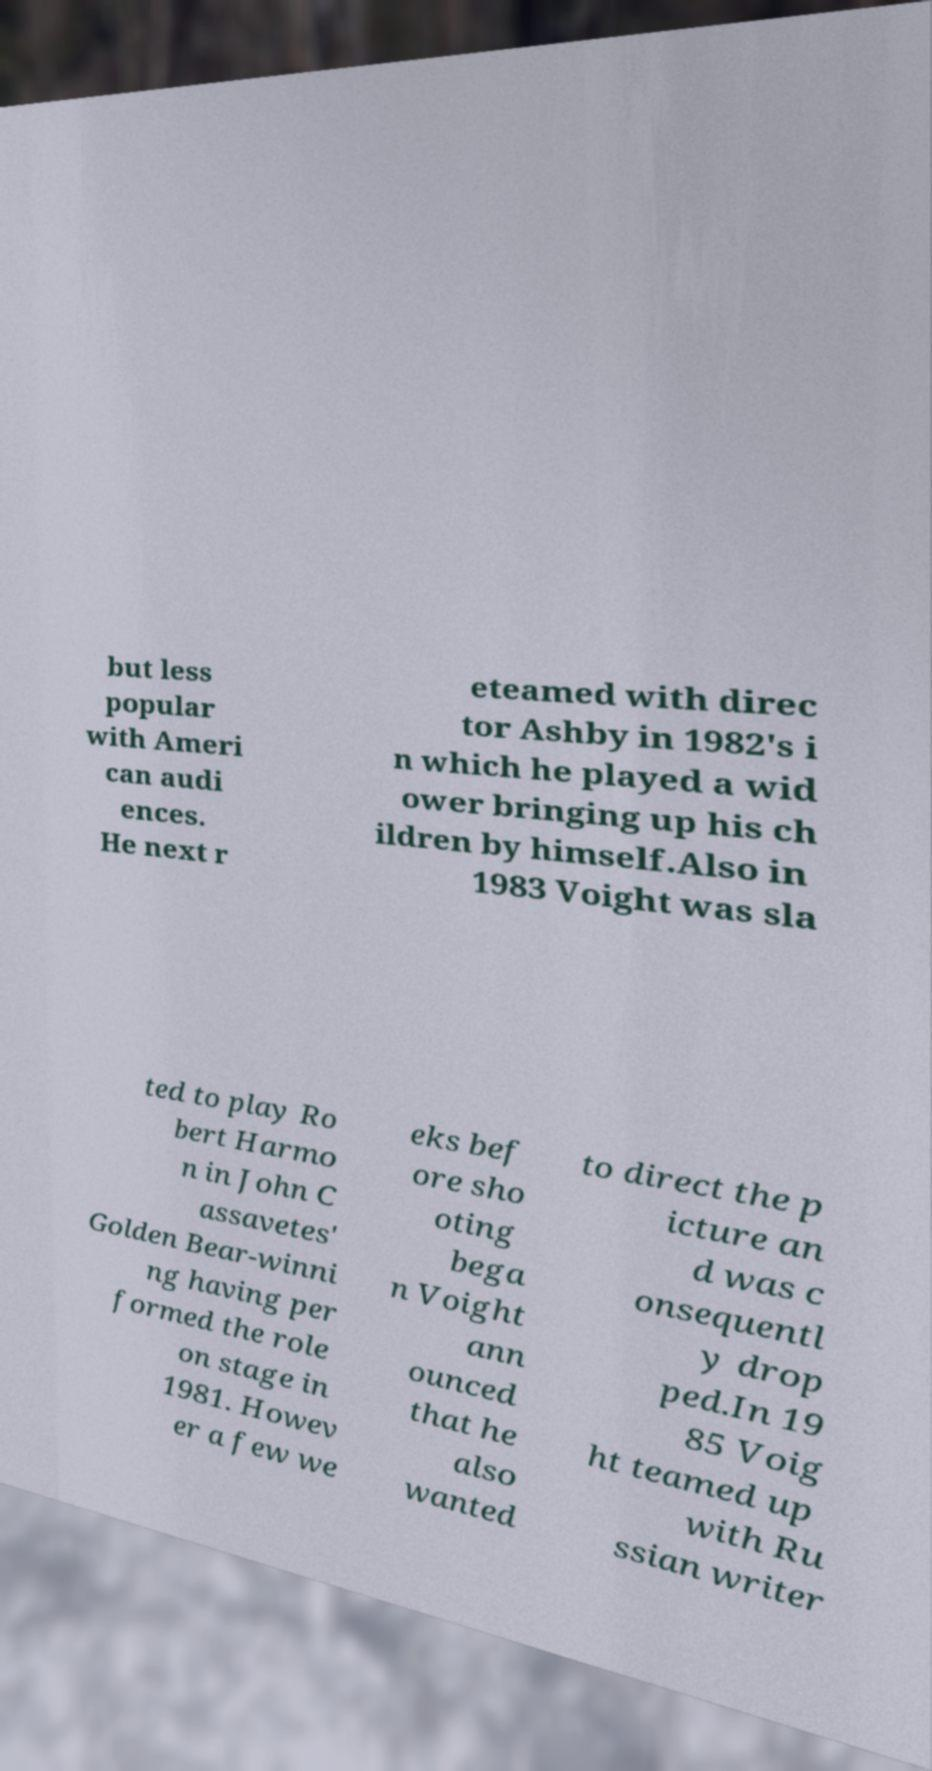Could you extract and type out the text from this image? but less popular with Ameri can audi ences. He next r eteamed with direc tor Ashby in 1982's i n which he played a wid ower bringing up his ch ildren by himself.Also in 1983 Voight was sla ted to play Ro bert Harmo n in John C assavetes' Golden Bear-winni ng having per formed the role on stage in 1981. Howev er a few we eks bef ore sho oting bega n Voight ann ounced that he also wanted to direct the p icture an d was c onsequentl y drop ped.In 19 85 Voig ht teamed up with Ru ssian writer 